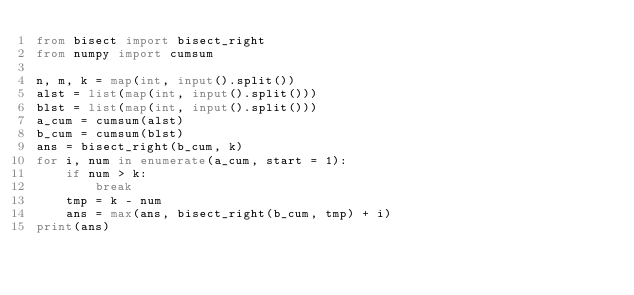Convert code to text. <code><loc_0><loc_0><loc_500><loc_500><_Python_>from bisect import bisect_right
from numpy import cumsum

n, m, k = map(int, input().split())
alst = list(map(int, input().split()))
blst = list(map(int, input().split()))
a_cum = cumsum(alst)
b_cum = cumsum(blst)
ans = bisect_right(b_cum, k)
for i, num in enumerate(a_cum, start = 1):
    if num > k:
        break
    tmp = k - num
    ans = max(ans, bisect_right(b_cum, tmp) + i)
print(ans)</code> 